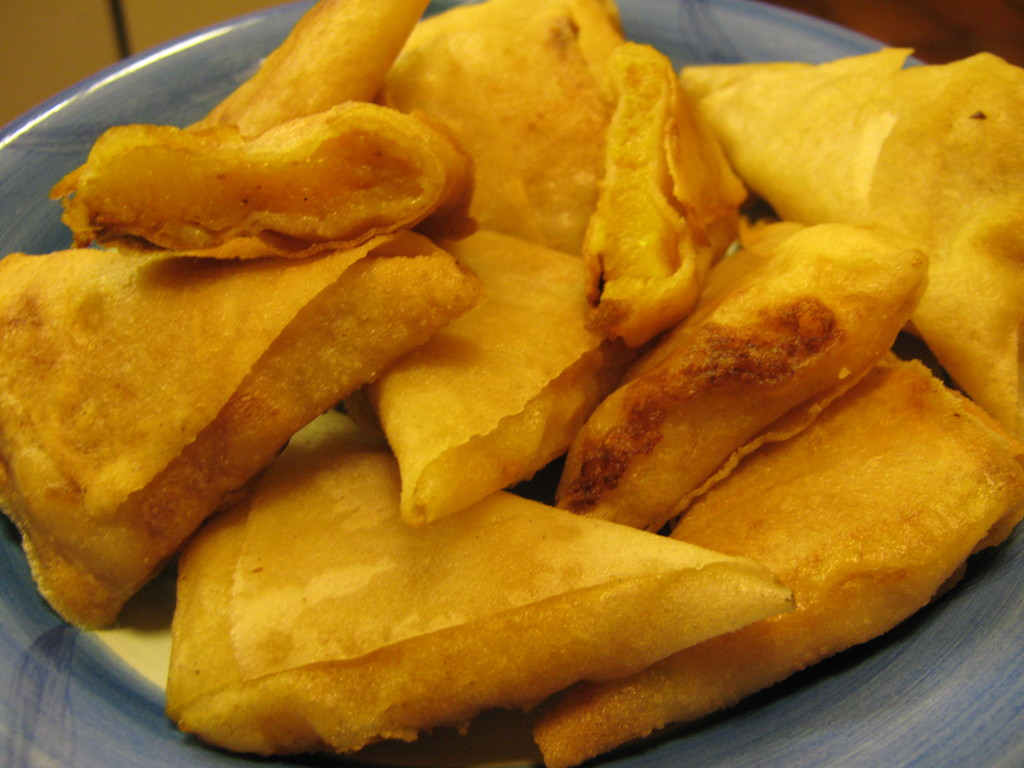Can I make this without fat or oil? While it is possible to cook potatoes without using fat or oil, the texture and taste may not be quite the same as the fried potatoes shown in the image. Here are a few suggestions for making baked or roasted potato wedges without added fat:

1. Cut the potatoes into wedges and toss them with a small amount of broth, water, or vegetable juice. The liquid will help them brown and crisp up in the oven.

2. Season the potato wedges with spices, herbs, or a bit of nutritional yeast before baking. This can help enhance the flavor without needing added fat.

3. Bake the potato wedges at a high temperature (400°F or higher) to encourage crisping on the outside while keeping the interior tender. You may need to flip them partway through.

4. Consider using an air fryer if you have one. Air frying potatoes can give a crispy exterior without needing oil.

The end result may not be identical to the deep-fried potatoes, but you can still achieve tasty, healthier baked or air-fried potato wedges without added fat. Experiment with different techniques and seasonings to find what works best for your preferences. 